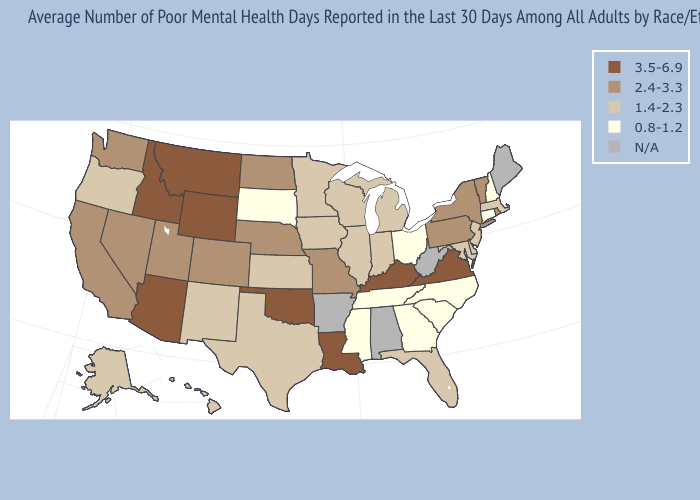Which states have the lowest value in the USA?
Give a very brief answer. Connecticut, Georgia, Mississippi, New Hampshire, North Carolina, Ohio, South Carolina, South Dakota, Tennessee. Name the states that have a value in the range 1.4-2.3?
Write a very short answer. Alaska, Delaware, Florida, Hawaii, Illinois, Indiana, Iowa, Kansas, Maryland, Massachusetts, Michigan, Minnesota, New Jersey, New Mexico, Oregon, Texas, Wisconsin. Which states hav the highest value in the Northeast?
Short answer required. New York, Pennsylvania, Rhode Island, Vermont. What is the value of Wyoming?
Concise answer only. 3.5-6.9. Name the states that have a value in the range 3.5-6.9?
Keep it brief. Arizona, Idaho, Kentucky, Louisiana, Montana, Oklahoma, Virginia, Wyoming. Does the map have missing data?
Quick response, please. Yes. What is the value of Maryland?
Concise answer only. 1.4-2.3. What is the lowest value in the USA?
Write a very short answer. 0.8-1.2. Does Tennessee have the highest value in the USA?
Give a very brief answer. No. Does the first symbol in the legend represent the smallest category?
Concise answer only. No. What is the lowest value in the USA?
Give a very brief answer. 0.8-1.2. Name the states that have a value in the range 3.5-6.9?
Be succinct. Arizona, Idaho, Kentucky, Louisiana, Montana, Oklahoma, Virginia, Wyoming. Which states hav the highest value in the South?
Be succinct. Kentucky, Louisiana, Oklahoma, Virginia. What is the value of North Carolina?
Write a very short answer. 0.8-1.2. 